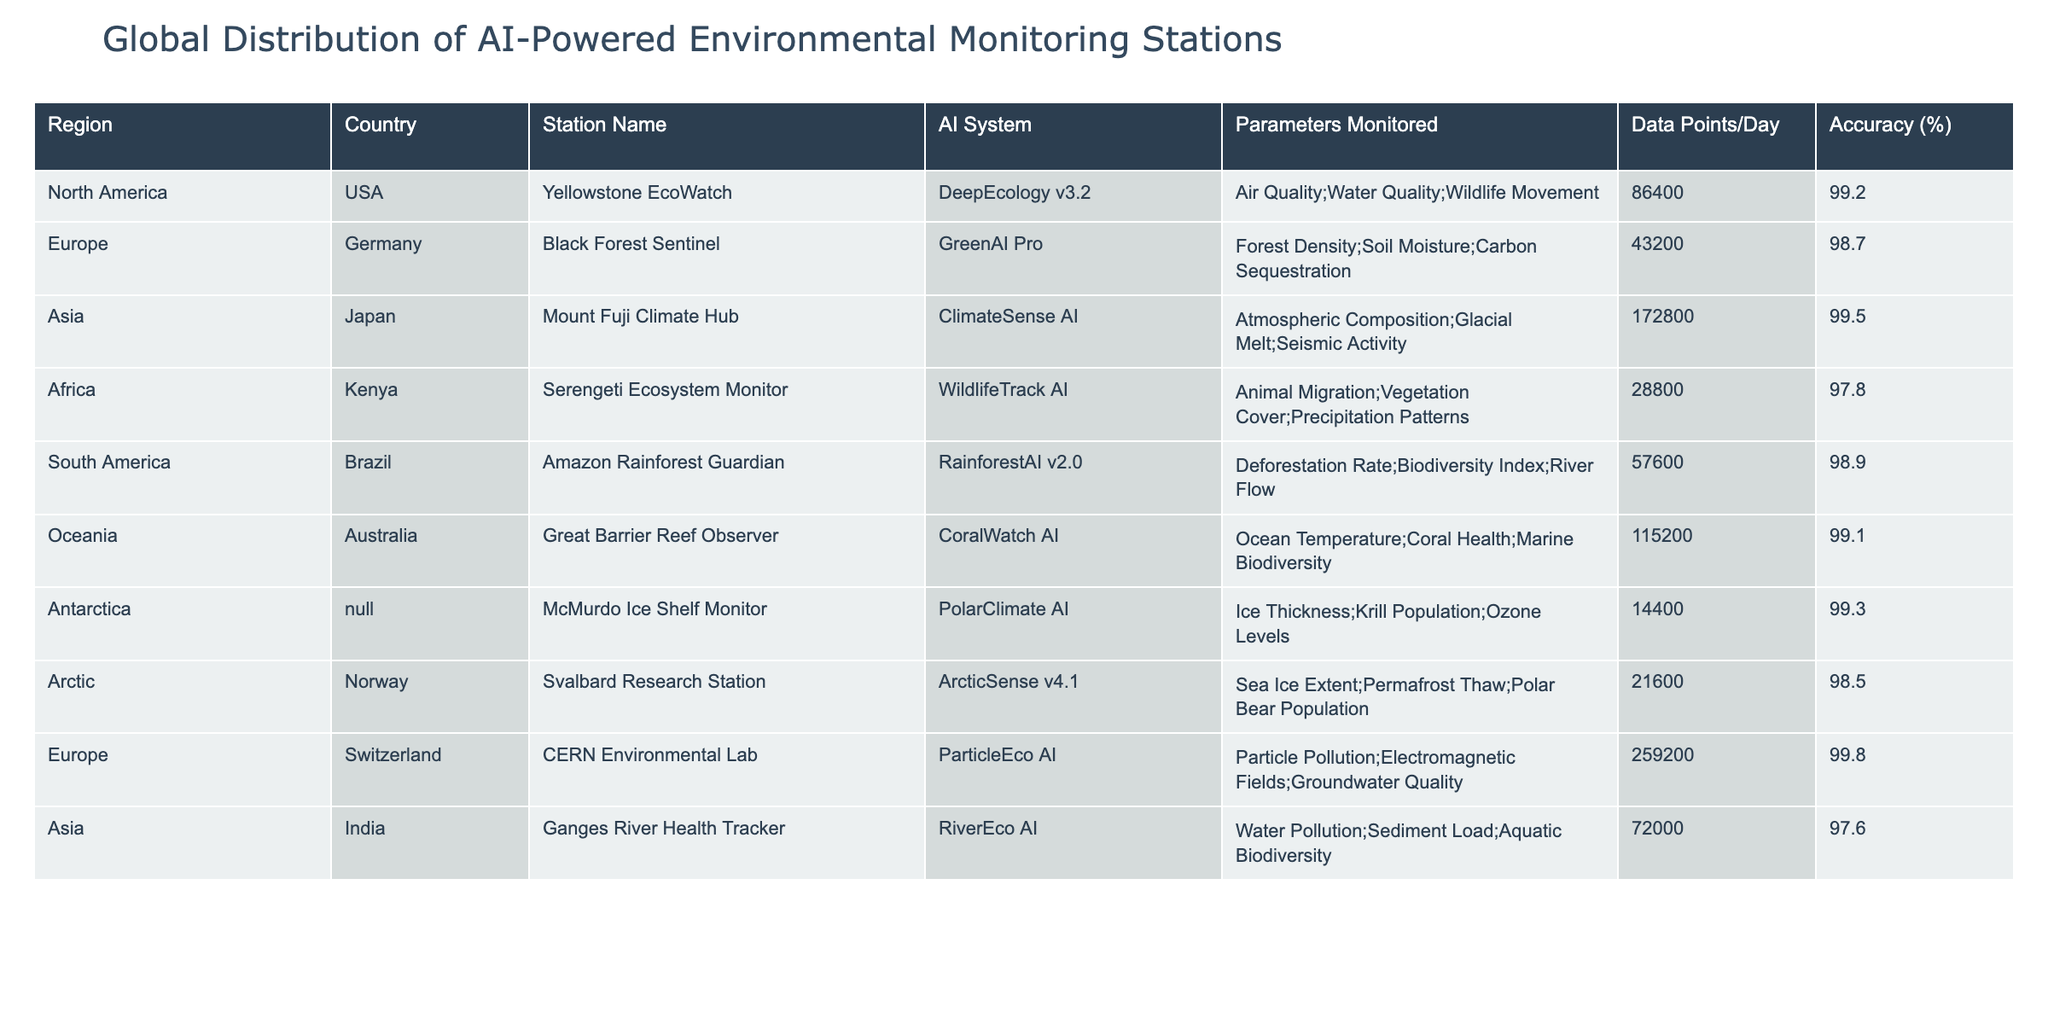What is the country with the highest accuracy in AI monitoring stations? The table shows the accuracy percentages for each AI monitoring station. By comparing the accuracies, Switzerland's CERN Environmental Lab has the highest accuracy of 99.8%.
Answer: Switzerland How many data points per day does the Mount Fuji Climate Hub collect? From the table, the Mount Fuji Climate Hub, located in Japan, collects 172800 data points per day.
Answer: 172800 Which region has the lowest accuracy in AI monitoring stations? To find the lowest accuracy, we look through the accuracy percentages listed in the table. The Serengeti Ecosystem Monitor in Kenya has the lowest accuracy at 97.8%.
Answer: Africa What is the average number of data points collected by the stations in Europe? There are two stations in Europe: Black Forest Sentinel (43200 data points) and CERN Environmental Lab (259200 data points). The sum is 43200 + 259200 = 302400. The average is 302400/2 = 151200.
Answer: 151200 Is the McMurdo Ice Shelf Monitor the only station located in Antarctica? The table indicates that the McMurdo Ice Shelf Monitor is the only station listed for Antarctica, thus making the statement true.
Answer: Yes What is the difference in data points per day between the Amazon Rainforest Guardian and the Ganges River Health Tracker? The Amazon Rainforest Guardian collects 57600 data points per day, whereas the Ganges River Health Tracker collects 72000. The difference is 72000 - 57600 = 14400.
Answer: 14400 Are there more AI monitoring stations in Asia than in North America? The table lists three stations in Asia (Mount Fuji Climate Hub, Ganges River Health Tracker) and one station in North America (Yellowstone EcoWatch). Thus, it confirms that Asia has more stations.
Answer: Yes Which AI system is used in the Arctic region's monitoring station? According to the table, the AI system for Norway's Svalbard Research Station in the Arctic region is ArcticSense v4.1.
Answer: ArcticSense v4.1 What is the total number of daily data points collected by all AI monitoring stations in South America? The table shows only one station in South America, the Amazon Rainforest Guardian, which collects 57600 data points per day. Thus, the total is simply 57600.
Answer: 57600 Which region has the highest number of data points collected per day by its monitoring station? Upon reviewing the data points, the Mount Fuji Climate Hub in Asia collects the highest at 172800 data points per day, making it the region with the highest data collection.
Answer: Asia 